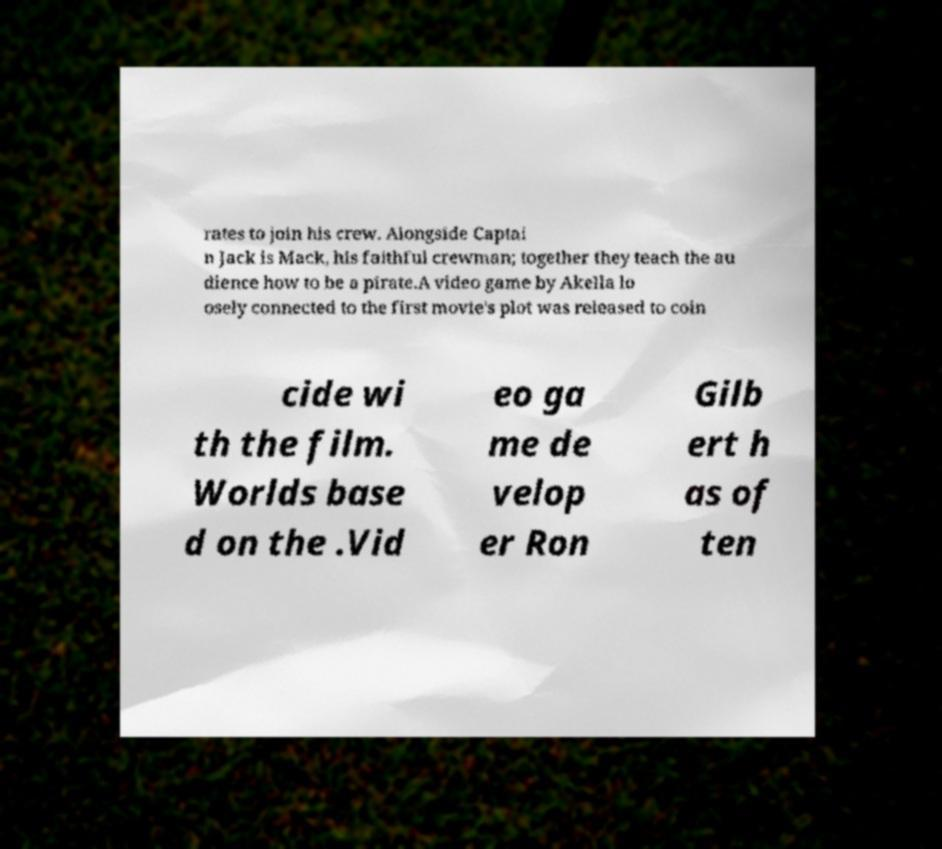Please read and relay the text visible in this image. What does it say? rates to join his crew. Alongside Captai n Jack is Mack, his faithful crewman; together they teach the au dience how to be a pirate.A video game by Akella lo osely connected to the first movie's plot was released to coin cide wi th the film. Worlds base d on the .Vid eo ga me de velop er Ron Gilb ert h as of ten 